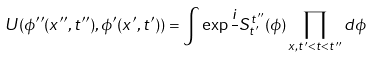Convert formula to latex. <formula><loc_0><loc_0><loc_500><loc_500>U ( \phi ^ { \prime \prime } ( x ^ { \prime \prime } , t ^ { \prime \prime } ) , \phi ^ { \prime } ( x ^ { \prime } , t ^ { \prime } ) ) = \int \exp \frac { i } { } S _ { t ^ { \prime } } ^ { t ^ { \prime \prime } } ( \phi ) \prod _ { x , t ^ { \prime } < t < t ^ { \prime \prime } } d \phi</formula> 